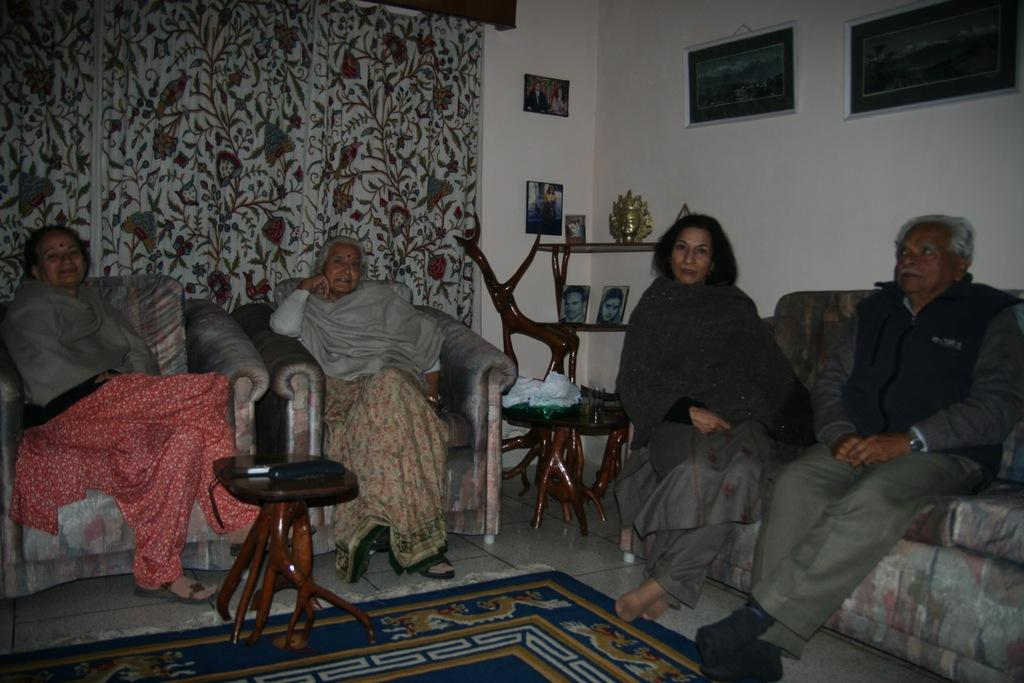How many people are sitting on the sofa in the image? There are four persons sitting on the sofa in the middle of the image. What can be seen on the wall in the background? There are photo frames on the wall in the background. What is located on the left side of the image? There is a curtain and a table on the left side of the image. What type of property is being controlled by the persons in the image? There is no indication in the image that the persons are controlling any property. 